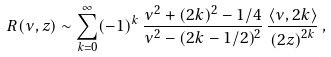Convert formula to latex. <formula><loc_0><loc_0><loc_500><loc_500>R ( \nu , z ) \sim \sum _ { k = 0 } ^ { \infty } ( - 1 ) ^ { k } \, \frac { \nu ^ { 2 } + ( 2 k ) ^ { 2 } - 1 / 4 } { \nu ^ { 2 } - ( 2 k - 1 / 2 ) ^ { 2 } } \, \frac { \langle \nu , 2 k \rangle } { \left ( 2 z \right ) ^ { 2 k } } \, ,</formula> 